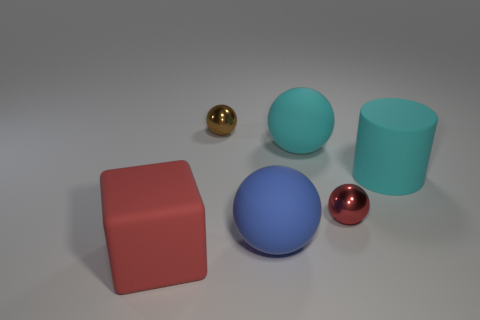Is there a large blue object that has the same material as the cube?
Ensure brevity in your answer.  Yes. Is there any other thing that has the same material as the large blue object?
Give a very brief answer. Yes. What is the color of the rubber cylinder?
Your response must be concise. Cyan. The big rubber thing that is the same color as the big cylinder is what shape?
Your answer should be very brief. Sphere. There is a cylinder that is the same size as the blue thing; what color is it?
Give a very brief answer. Cyan. What number of shiny objects are either small brown objects or spheres?
Your answer should be compact. 2. What number of matte objects are both behind the blue ball and in front of the big blue rubber object?
Keep it short and to the point. 0. Is there anything else that has the same shape as the red matte object?
Offer a terse response. No. How many other things are there of the same size as the cyan rubber ball?
Provide a succinct answer. 3. There is a red object that is in front of the blue sphere; is it the same size as the blue rubber ball on the right side of the brown metallic object?
Your answer should be very brief. Yes. 